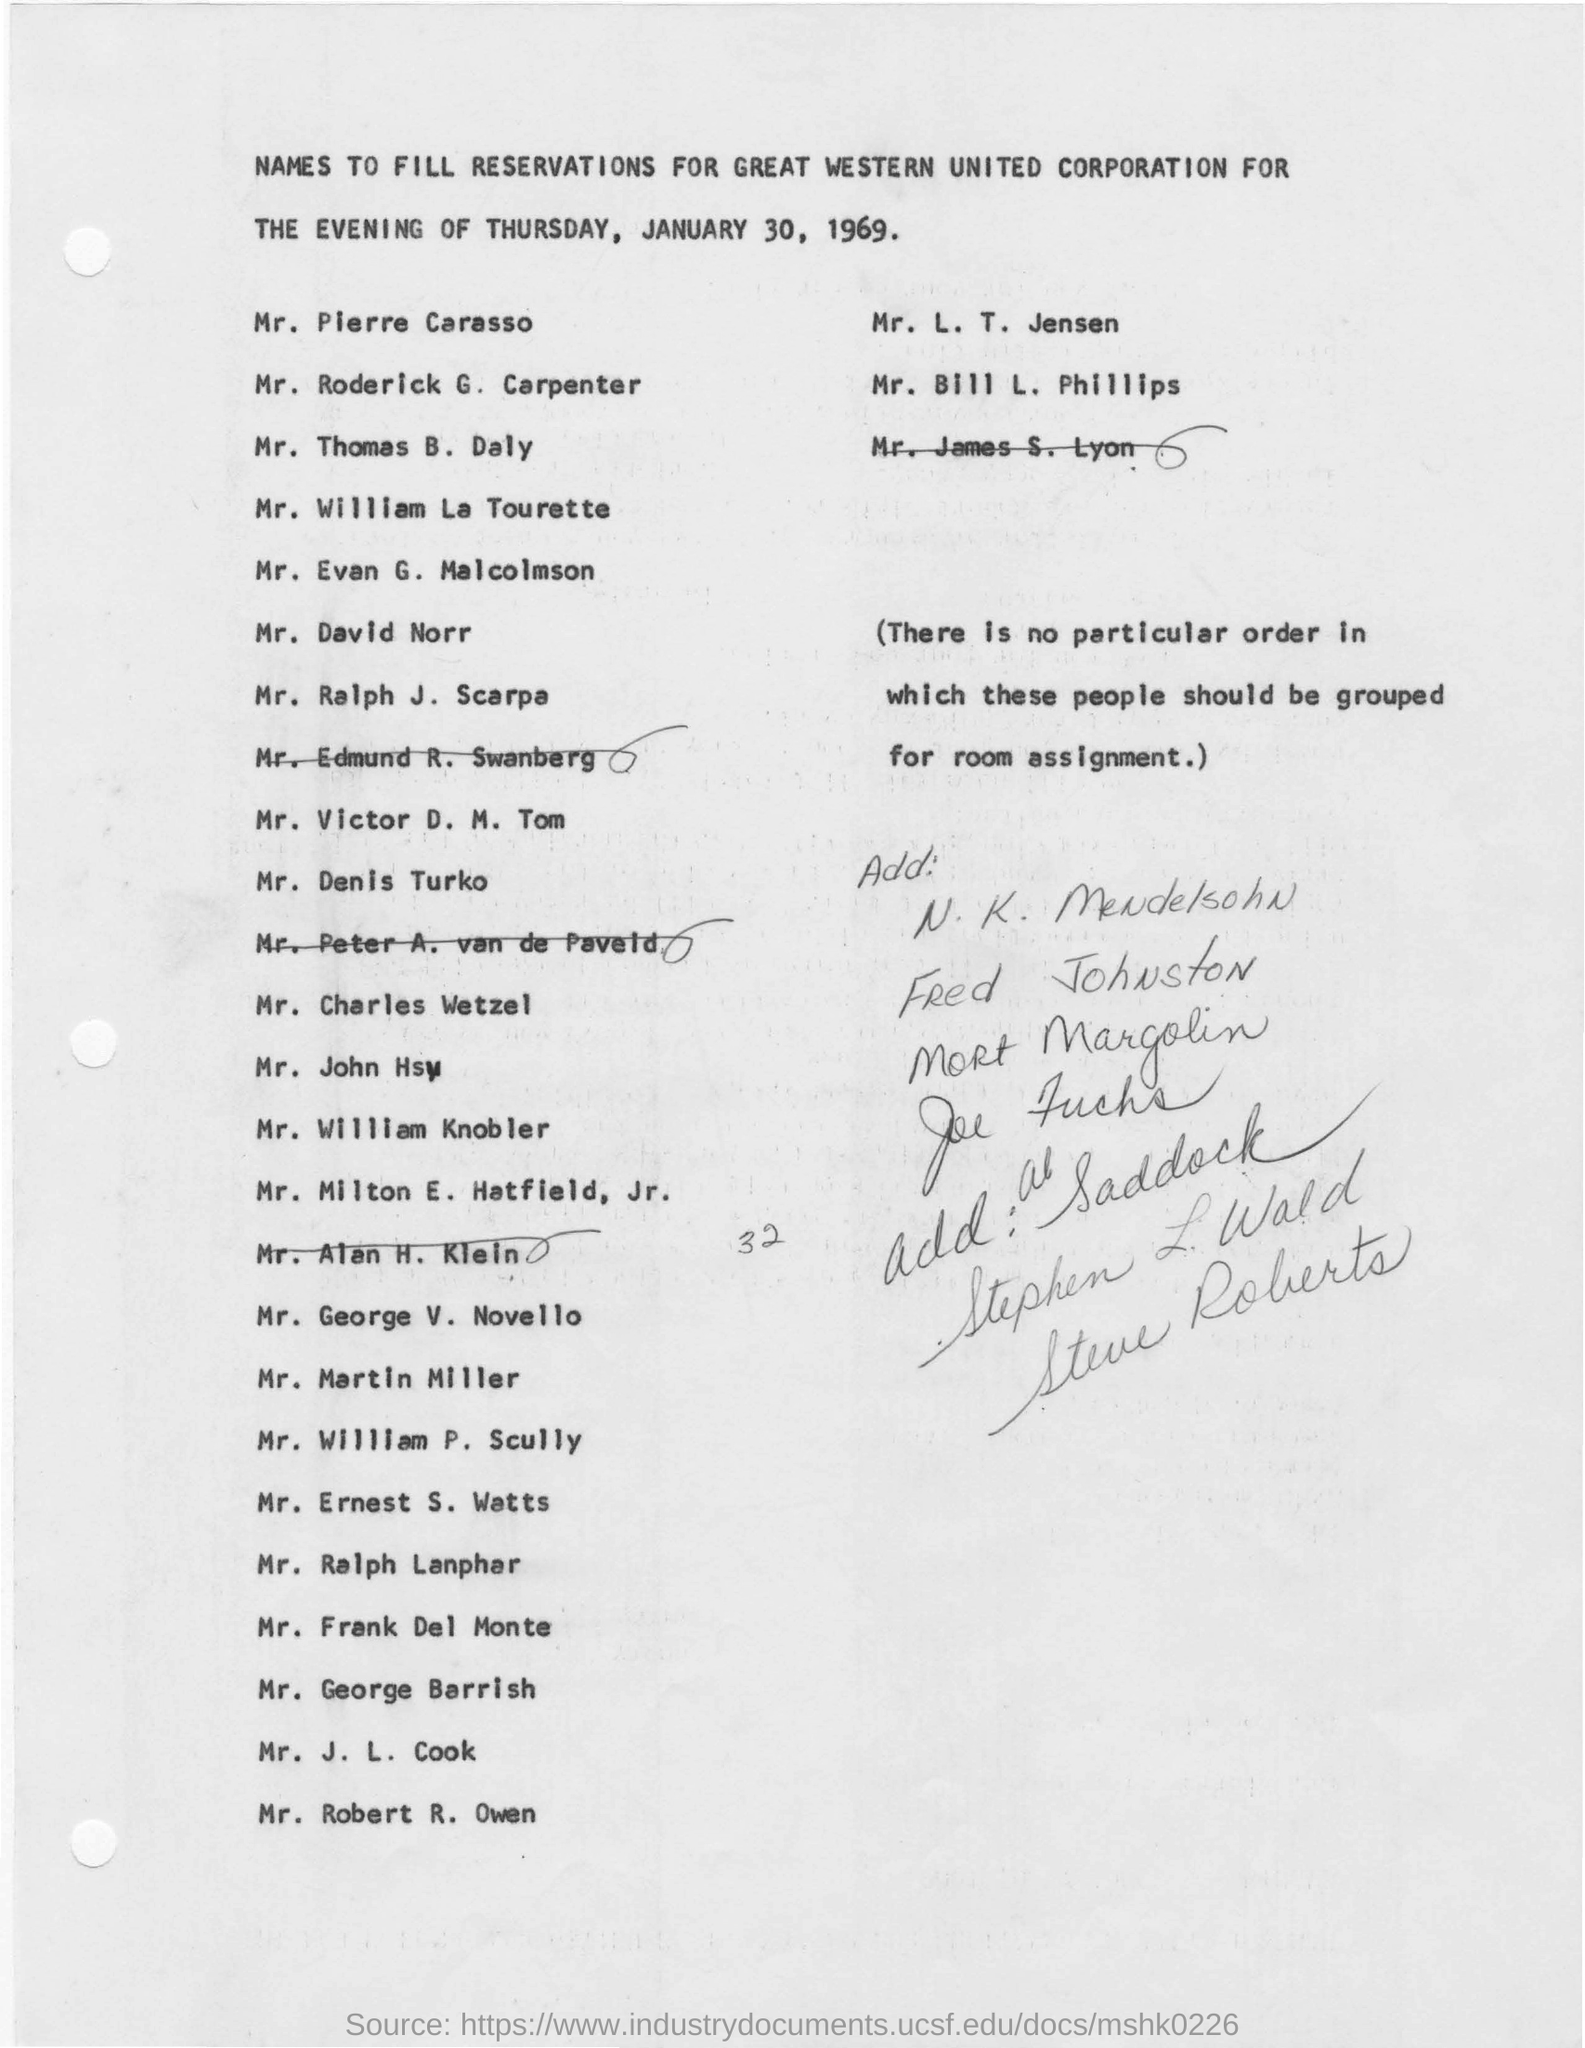List a handful of essential elements in this visual. The purpose of the letter is to request the filling of reservations for Great Western United Corporation for the evening of Thursday, January 30, 1969. 